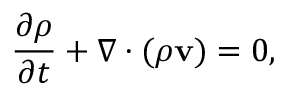<formula> <loc_0><loc_0><loc_500><loc_500>{ \frac { \partial \rho } { \partial t } } + \nabla \cdot ( \rho v ) = 0 ,</formula> 